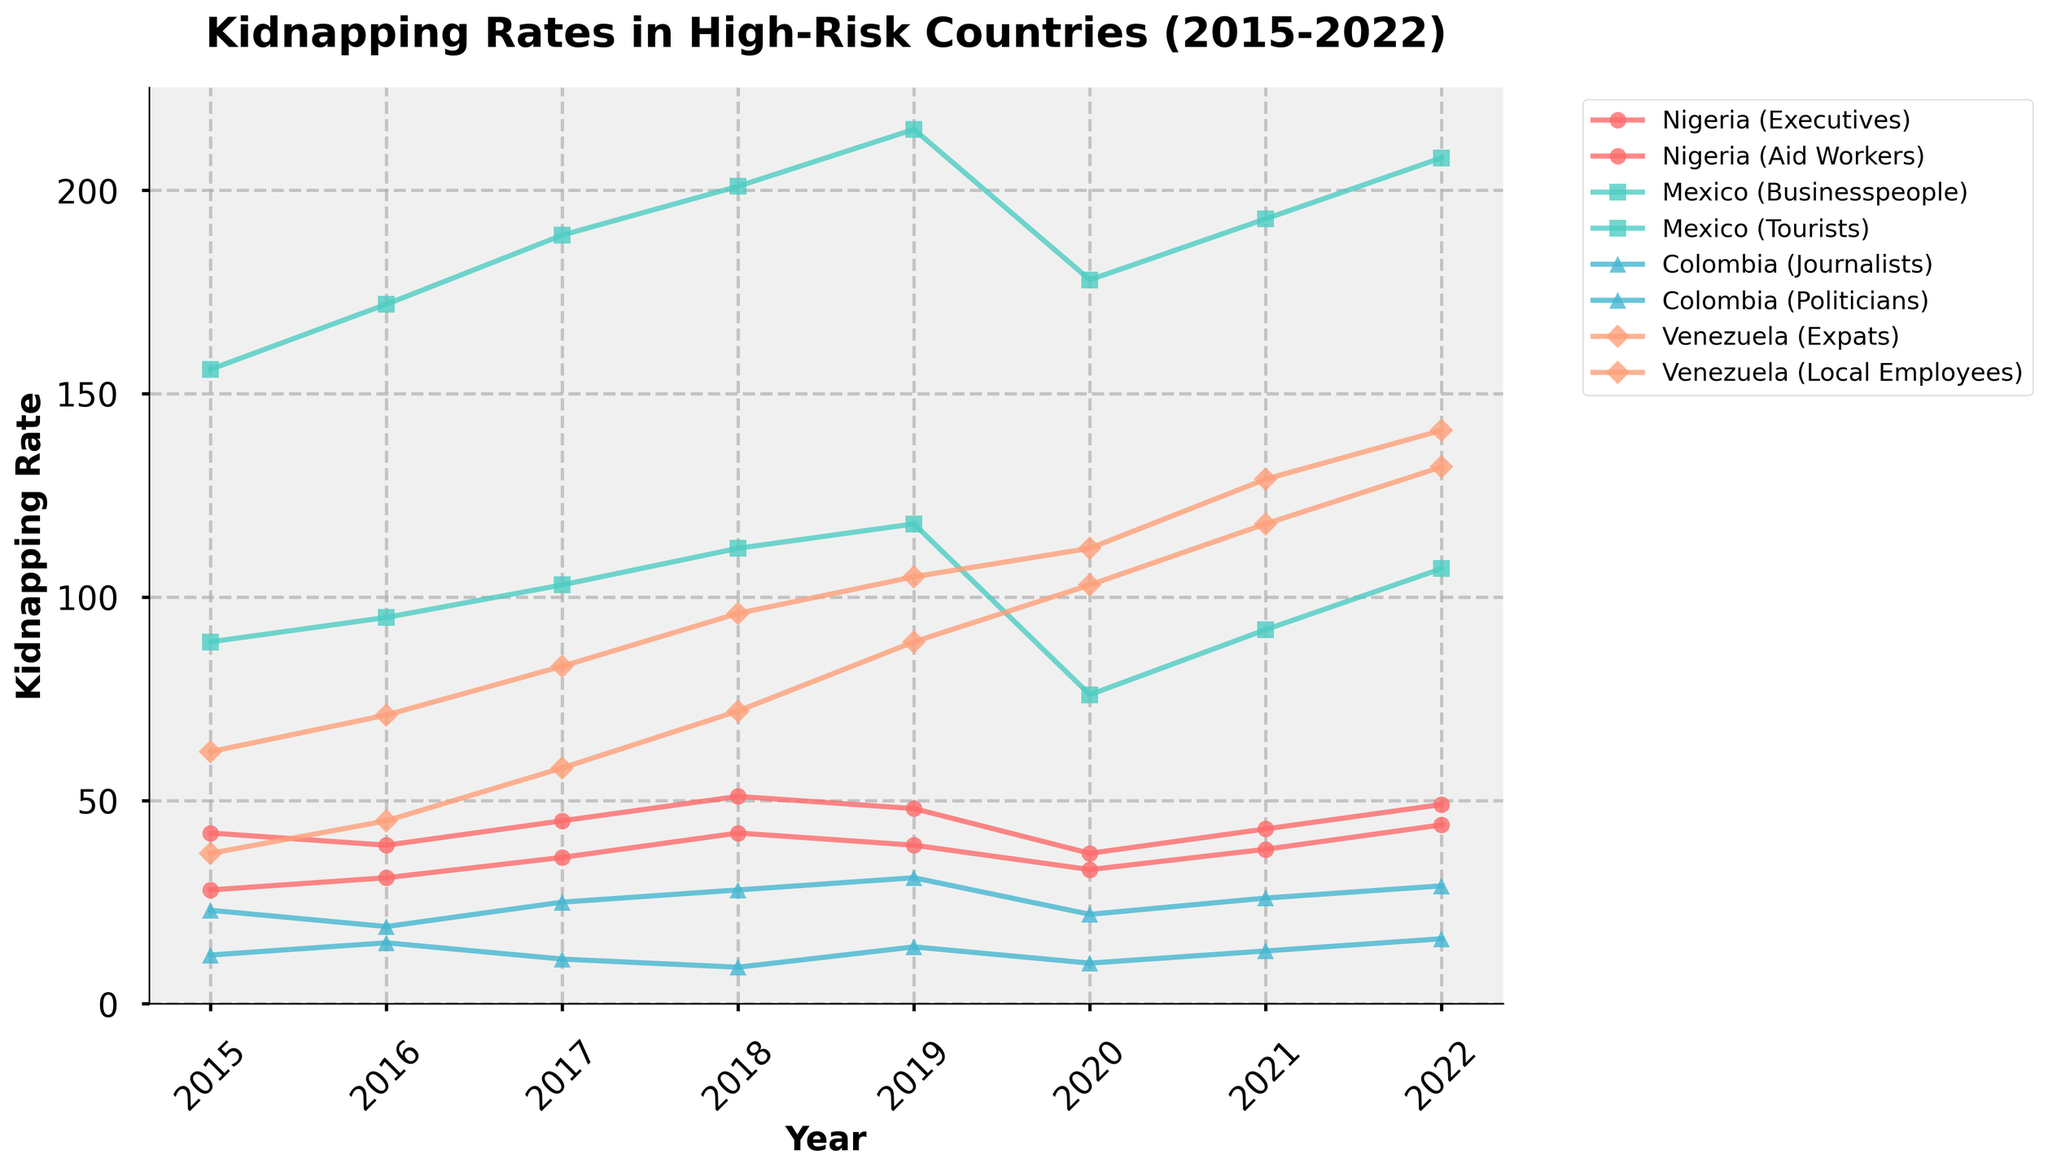Which country had the highest kidnapping rate for aid workers in 2019? To determine the country with the highest kidnapping rate for aid workers in 2019, look at the '2019' data points for profiles containing "Aid Workers". Nigeria is the only country listed with aid workers and the rate is 39.
Answer: Nigeria Which victim profile saw the steepest increase in kidnappings in Venezuela from 2015 to 2022? Compare the values of all Venezuelan victim profiles from 2015 to 2022. The profile "Expats" increased from 37 to 132, which is the steepest increase.
Answer: Expats Between which two years did journalists in Colombia experience the largest increase in kidnappings? Look at the kidnapping rates for journalists in Colombia across the years and identify the largest increase. The biggest jump is from 2021 to 2022 (from 13 to 16).
Answer: 2021 to 2022 How did the kidnapping rate for businesspeople in Mexico in 2020 compare to that in 2021? Compare the data points for "Mexico (Businesspeople)" in 2020 and 2021. The rate increased from 178 to 193.
Answer: Increased What is the overall trend in kidnapping rates for local employees in Venezuela from 2015 to 2022? Observe the data points for "Venezuela (Local Employees)" over the years. There is a clear upward trend from 62 in 2015 to 141 in 2022.
Answer: Upward trend Which country's executives experienced a reduction in kidnapping rates in 2020 compared to the previous year? Look at the "Executives" data points for each country in 2019 and 2020. In Nigeria, the rate went down from 48 to 37.
Answer: Nigeria How much did the kidnapping rate for politicians in Colombia change from 2015 to 2016? Look at "Colombia (Politicians)" and calculate the difference between 2015 and 2016: 19 - 23 = -4.
Answer: Decreased by 4 What was the difference in the kidnapping rates of expats and local employees in Venezuela in 2018? Compare the two values for expats and local employees in Venezuela in 2018: 72 (local employees) - 45 (expats) = 27.
Answer: 27 Which year had the highest overall kidnapping rate for all victim profiles combined in Mexico? Sum all the Mexican victim profiles for each year and identify the year with the maximum sum. 2022 has the highest combined rate: 208 (businesspeople) + 107 (tourists) = 315.
Answer: 2022 What was the average rate of kidnapping for journalists in Colombia over the given period? Add up all the values related to "Colombia (Journalists)" and divide by the number of years (2015-2022): (12+15+11+9+14+10+13+16)/8 = 12.5
Answer: 12.5 